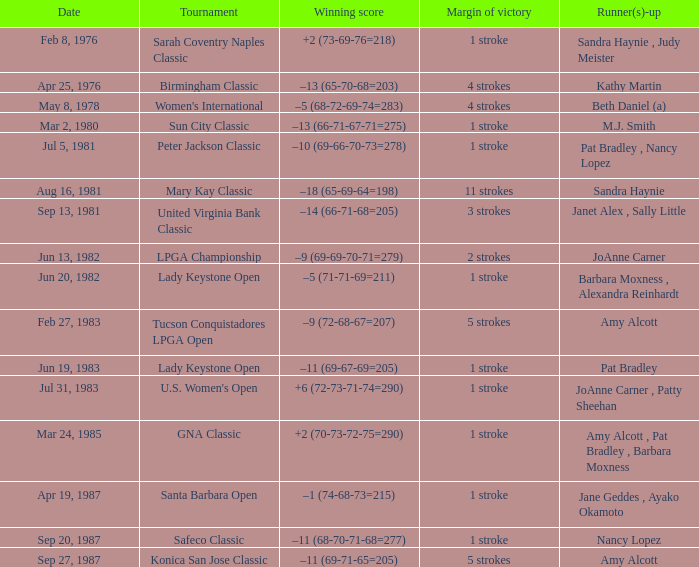What is the tournament when the winning score is –9 (69-69-70-71=279)? LPGA Championship. 